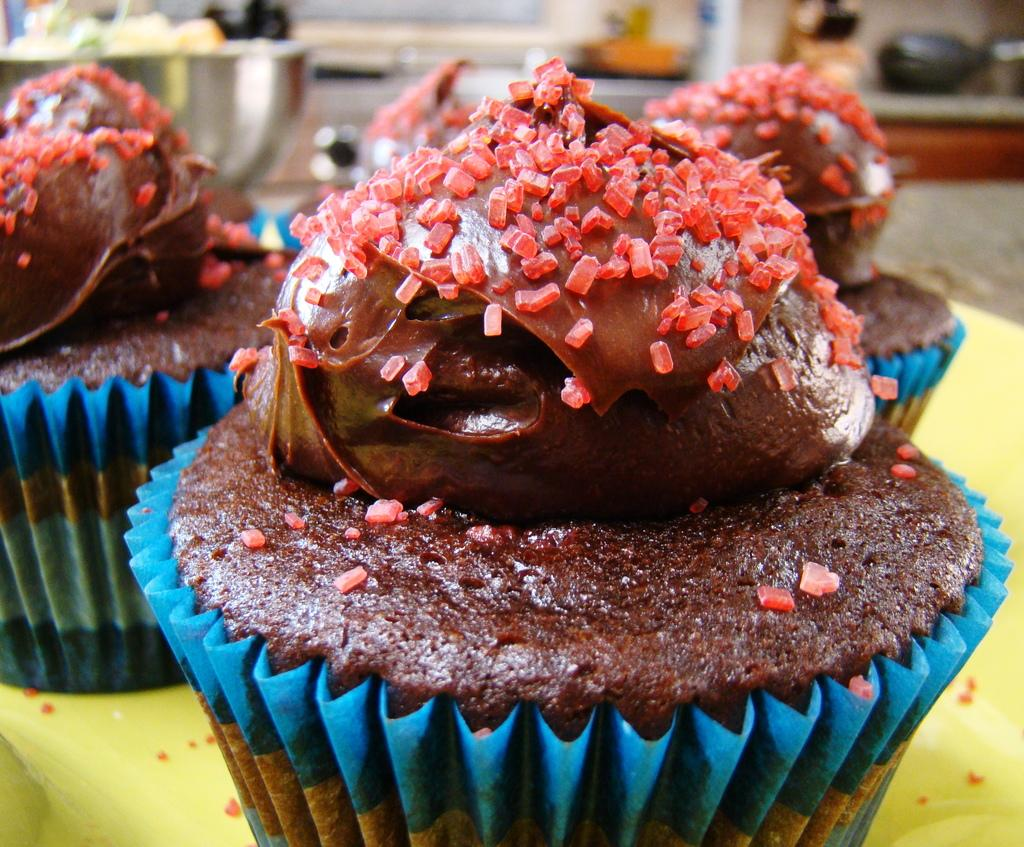What type of dessert can be seen in the image? There are cupcakes with creams in the image. Can you describe the background of the image? The background of the image is blurry. What part of the cow is visible in the image? There is no cow present in the image; it features cupcakes with creams and a blurry background. 